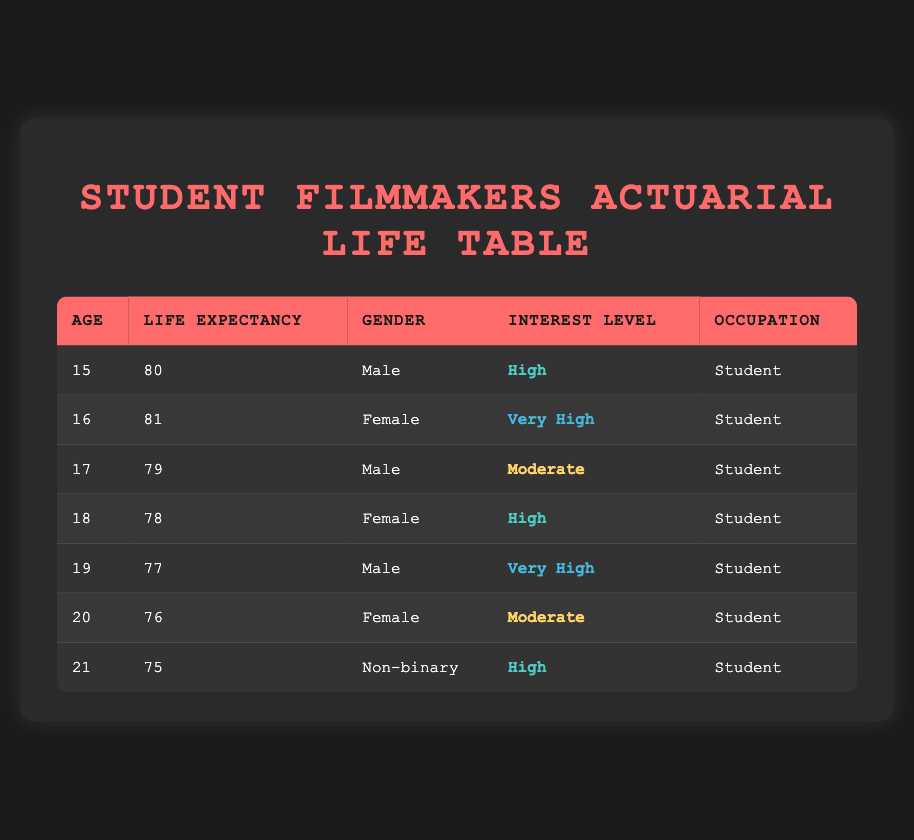What is the life expectancy for 16-year-old female student filmmakers? The table lists the life expectancy for 16-year-old female student filmmakers as 81.
Answer: 81 How many male student filmmakers have a life expectancy below 79? There are two male student filmmakers (age 17 and age 19) with life expectancies of 79 and 77, respectively. Since we want those below 79, we only consider the age 19 data point, which has a life expectancy of 77. Thus, the count is one.
Answer: 1 What is the difference in life expectancy between the youngest (age 15) and the oldest (age 21) student filmmakers? The life expectancy for the youngest (age 15) is 80, and for the oldest (age 21) is 75. The difference is calculated as 80 - 75 = 5.
Answer: 5 Do any of the female student filmmakers have a life expectancy higher than 80? The 16-year-old female has a life expectancy of 81, which is higher than 80. Hence, the answer is yes.
Answer: Yes What is the average life expectancy for all student filmmakers aged 15 to 20? To calculate the average, we sum the life expectancies for ages 15, 16, 17, 18, 19, and 20. The values are (80 + 81 + 79 + 78 + 77 + 76) = 471. The count of ages considered is 6, so the average is 471/6 ≈ 78.5.
Answer: 78.5 Which gender has the highest life expectancy when comparing them at age 19? The life expectancy for the 19-year-old male is 77, and there are no 19-year-old females to compare. Therefore, the highest life expectancy at this age is for the male.
Answer: Male Count the number of student filmmakers aged 18 and over who have an interest level rated as "High." There are two student filmmakers aged 18 and over with a "High" interest level: the 18-year-old female and the 21-year-old non-binary student. Therefore, the count is 2.
Answer: 2 Is the interest level of the 17-year-old male student filmmaker considered "Very High"? The interest level for the 17-year-old male student filmmaker is categorized as "Moderate", not "Very High". Thus, the answer is no.
Answer: No 